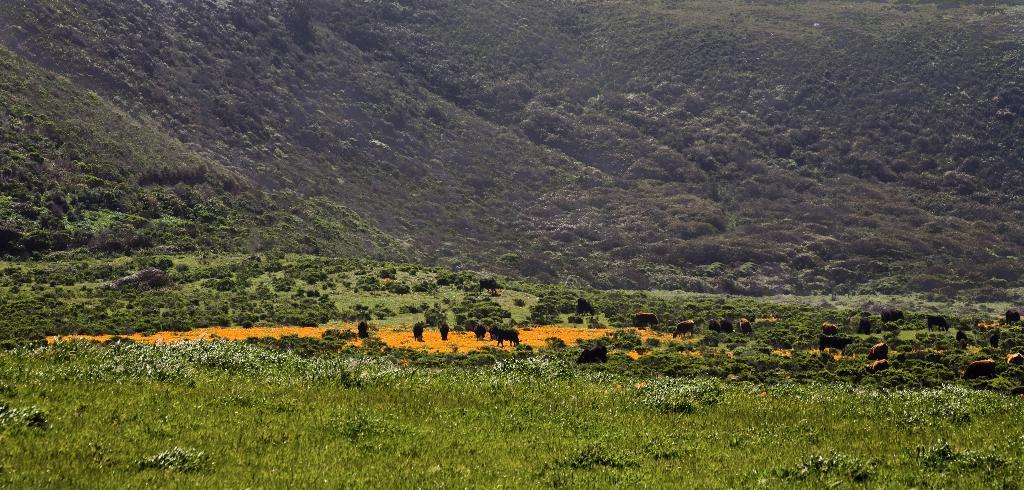Can you describe this image briefly? In this image animals are grazing on the field, in the background there are mountains and trees. 